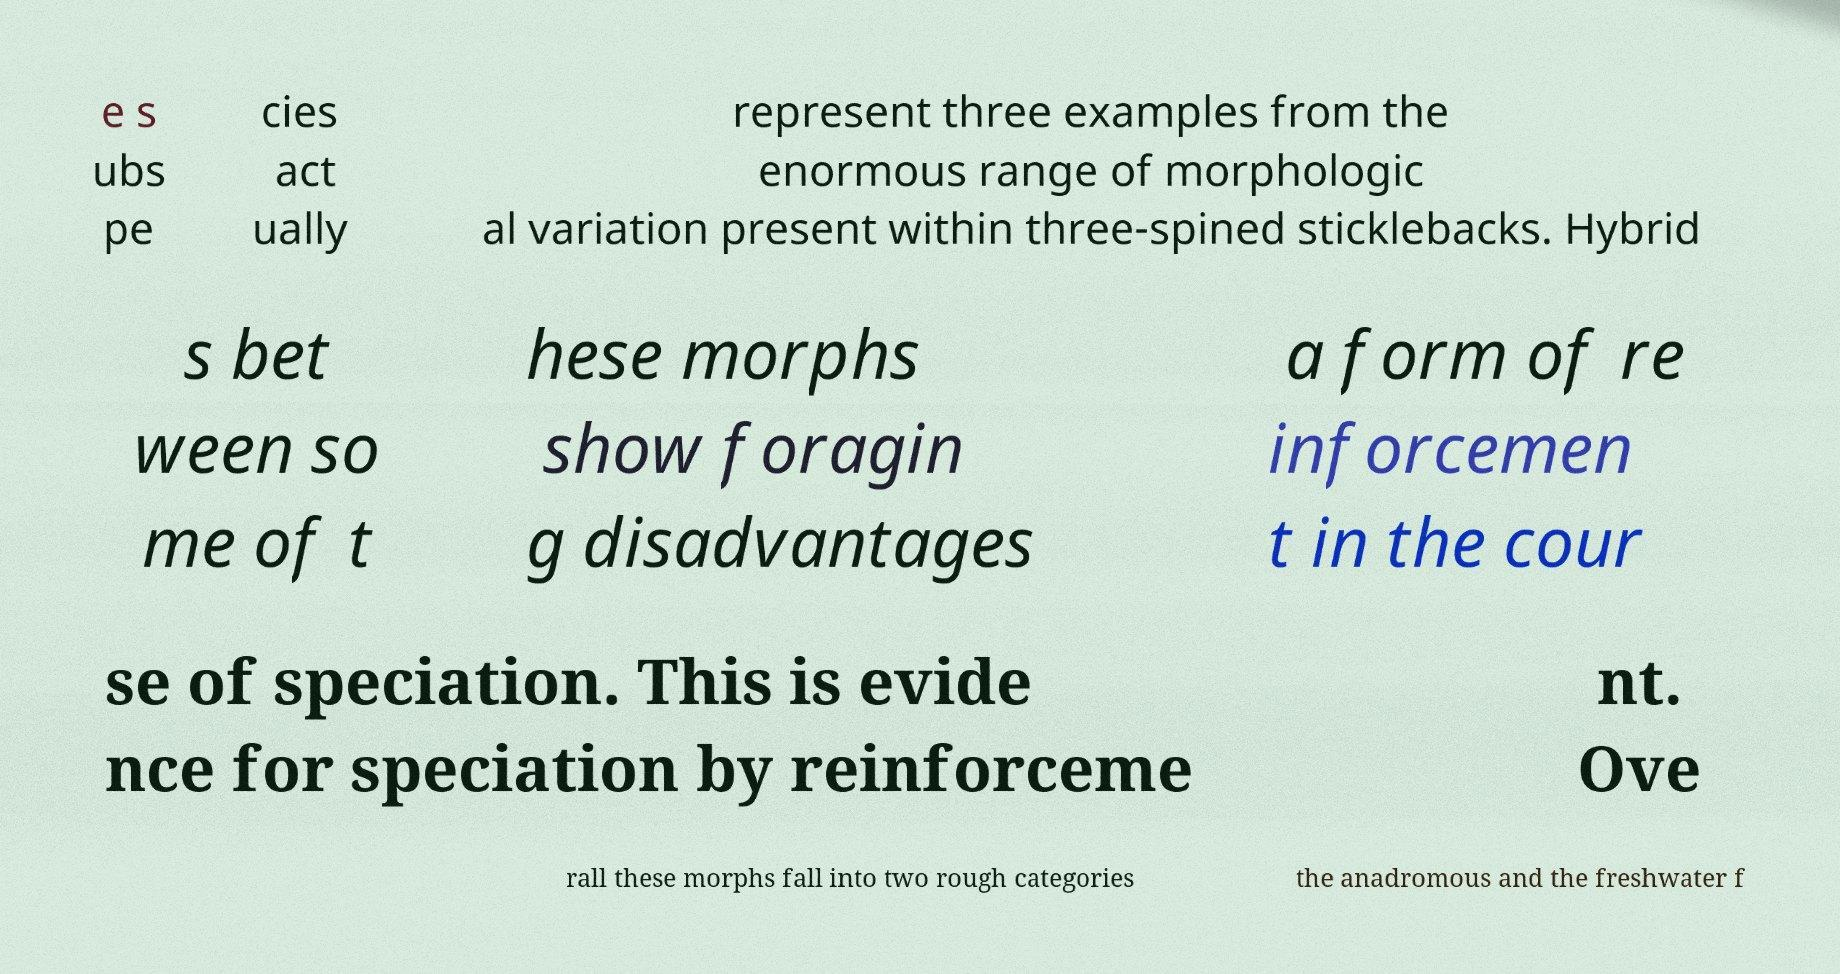What messages or text are displayed in this image? I need them in a readable, typed format. e s ubs pe cies act ually represent three examples from the enormous range of morphologic al variation present within three-spined sticklebacks. Hybrid s bet ween so me of t hese morphs show foragin g disadvantages a form of re inforcemen t in the cour se of speciation. This is evide nce for speciation by reinforceme nt. Ove rall these morphs fall into two rough categories the anadromous and the freshwater f 